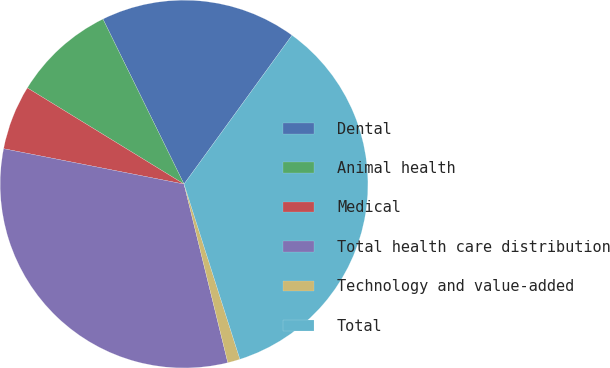Convert chart to OTSL. <chart><loc_0><loc_0><loc_500><loc_500><pie_chart><fcel>Dental<fcel>Animal health<fcel>Medical<fcel>Total health care distribution<fcel>Technology and value-added<fcel>Total<nl><fcel>17.26%<fcel>8.97%<fcel>5.68%<fcel>31.91%<fcel>1.09%<fcel>35.1%<nl></chart> 